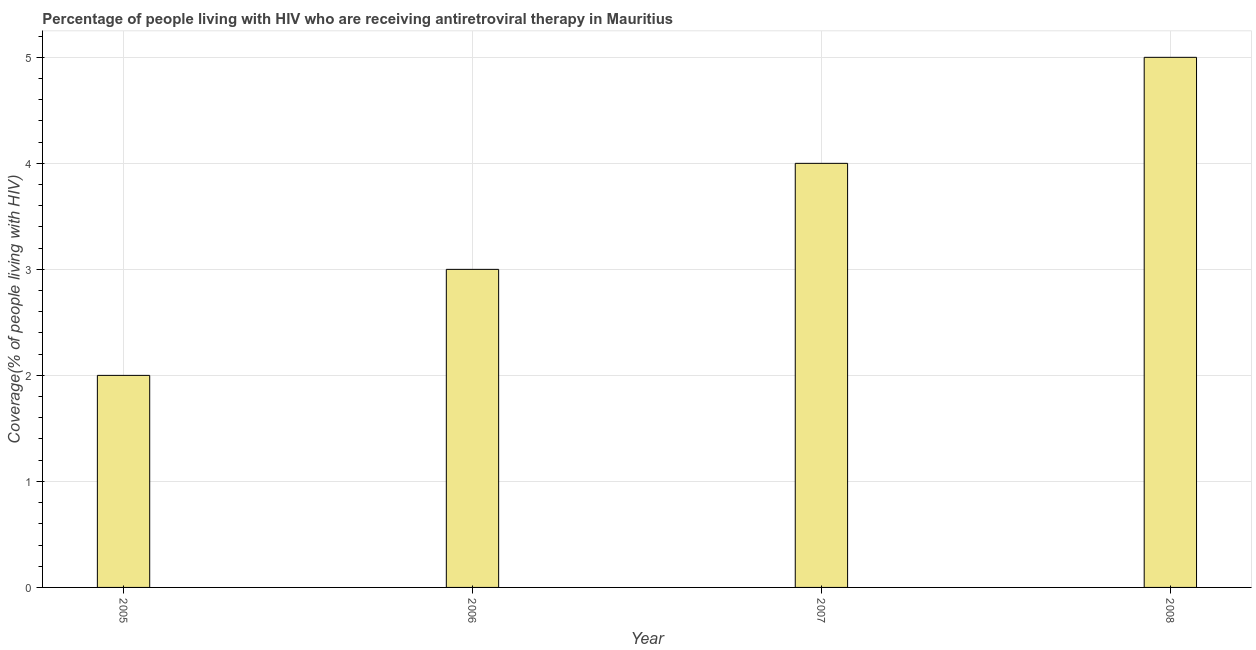Does the graph contain grids?
Offer a terse response. Yes. What is the title of the graph?
Your answer should be compact. Percentage of people living with HIV who are receiving antiretroviral therapy in Mauritius. What is the label or title of the Y-axis?
Offer a very short reply. Coverage(% of people living with HIV). Across all years, what is the minimum antiretroviral therapy coverage?
Offer a very short reply. 2. In which year was the antiretroviral therapy coverage minimum?
Make the answer very short. 2005. What is the difference between the antiretroviral therapy coverage in 2007 and 2008?
Your answer should be compact. -1. What is the average antiretroviral therapy coverage per year?
Offer a very short reply. 3. Do a majority of the years between 2008 and 2006 (inclusive) have antiretroviral therapy coverage greater than 2.4 %?
Your answer should be very brief. Yes. What is the ratio of the antiretroviral therapy coverage in 2005 to that in 2006?
Make the answer very short. 0.67. Is the difference between the antiretroviral therapy coverage in 2005 and 2008 greater than the difference between any two years?
Provide a short and direct response. Yes. What is the difference between the highest and the second highest antiretroviral therapy coverage?
Keep it short and to the point. 1. Is the sum of the antiretroviral therapy coverage in 2006 and 2008 greater than the maximum antiretroviral therapy coverage across all years?
Provide a succinct answer. Yes. What is the difference between the highest and the lowest antiretroviral therapy coverage?
Provide a succinct answer. 3. In how many years, is the antiretroviral therapy coverage greater than the average antiretroviral therapy coverage taken over all years?
Provide a succinct answer. 2. What is the Coverage(% of people living with HIV) in 2005?
Keep it short and to the point. 2. What is the difference between the Coverage(% of people living with HIV) in 2005 and 2006?
Make the answer very short. -1. What is the difference between the Coverage(% of people living with HIV) in 2006 and 2008?
Your answer should be compact. -2. What is the ratio of the Coverage(% of people living with HIV) in 2005 to that in 2006?
Keep it short and to the point. 0.67. What is the ratio of the Coverage(% of people living with HIV) in 2006 to that in 2007?
Your answer should be very brief. 0.75. What is the ratio of the Coverage(% of people living with HIV) in 2006 to that in 2008?
Ensure brevity in your answer.  0.6. 